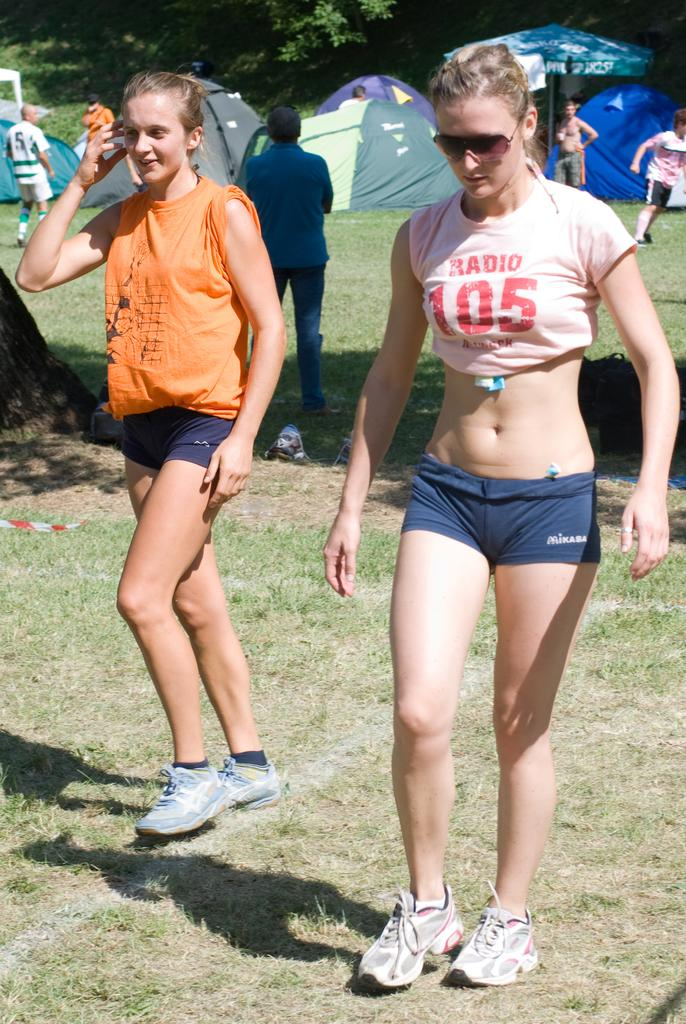How many ladies are in the image? There are two ladies in the image. What are the ladies doing in the image? The ladies are walking. Can you describe the background of the image? There are people standing and tents visible in the background of the image, along with trees. What type of bed can be seen in the image? There is no bed present in the image. Can you describe the haircut of the lady on the left? The image does not provide enough detail to describe the haircut of the lady on the left. --- Facts: 1. There is a car in the image. 2. The car is red. 3. The car has four wheels. 4. There are people sitting inside the car. 5. The car is parked on the street. Absurd Topics: fish, mountain, guitar Conversation: What is the color of the car in the image? The car is red. How many wheels does the car have? The car has four wheels. What is the car's current status in the image? The car is parked on the street. Can you describe the occupants of the car? There are people sitting inside the car. Reasoning: Let's think step by step in order to produce the conversation. We start by identifying the main subject in the image, which is the car. Then, we describe its color and number of wheels. Next, we expand the conversation to include details about the car's status (parked) and the presence of people inside. Each question is designed to elicit a specific detail about the image that is known from the provided facts. Absurd Question/Answer: Can you tell me how many fish are swimming in the car's engine? There are no fish present in the image, and the car's engine is not visible. What type of guitar is the person in the backseat playing? There is no guitar present in the image, and no one is playing an instrument. 